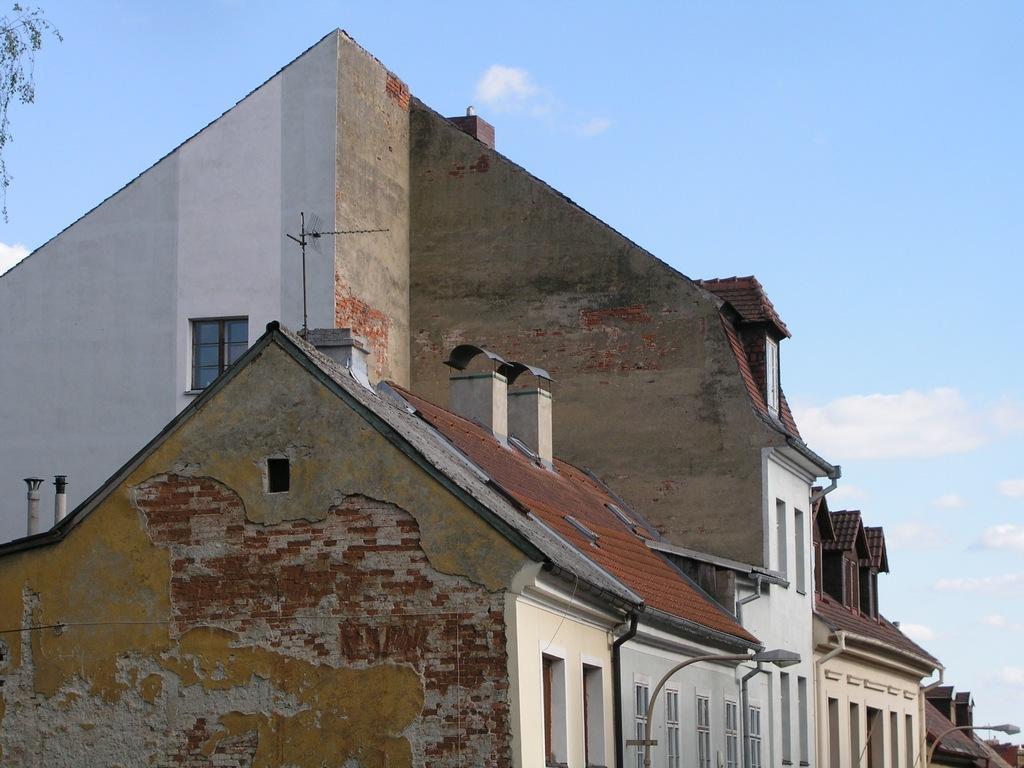Could you give a brief overview of what you see in this image? In this picture we can see buildings, lights and poles. In the background of the image we can see the sky. In the top left side of the image we can see leaves. 